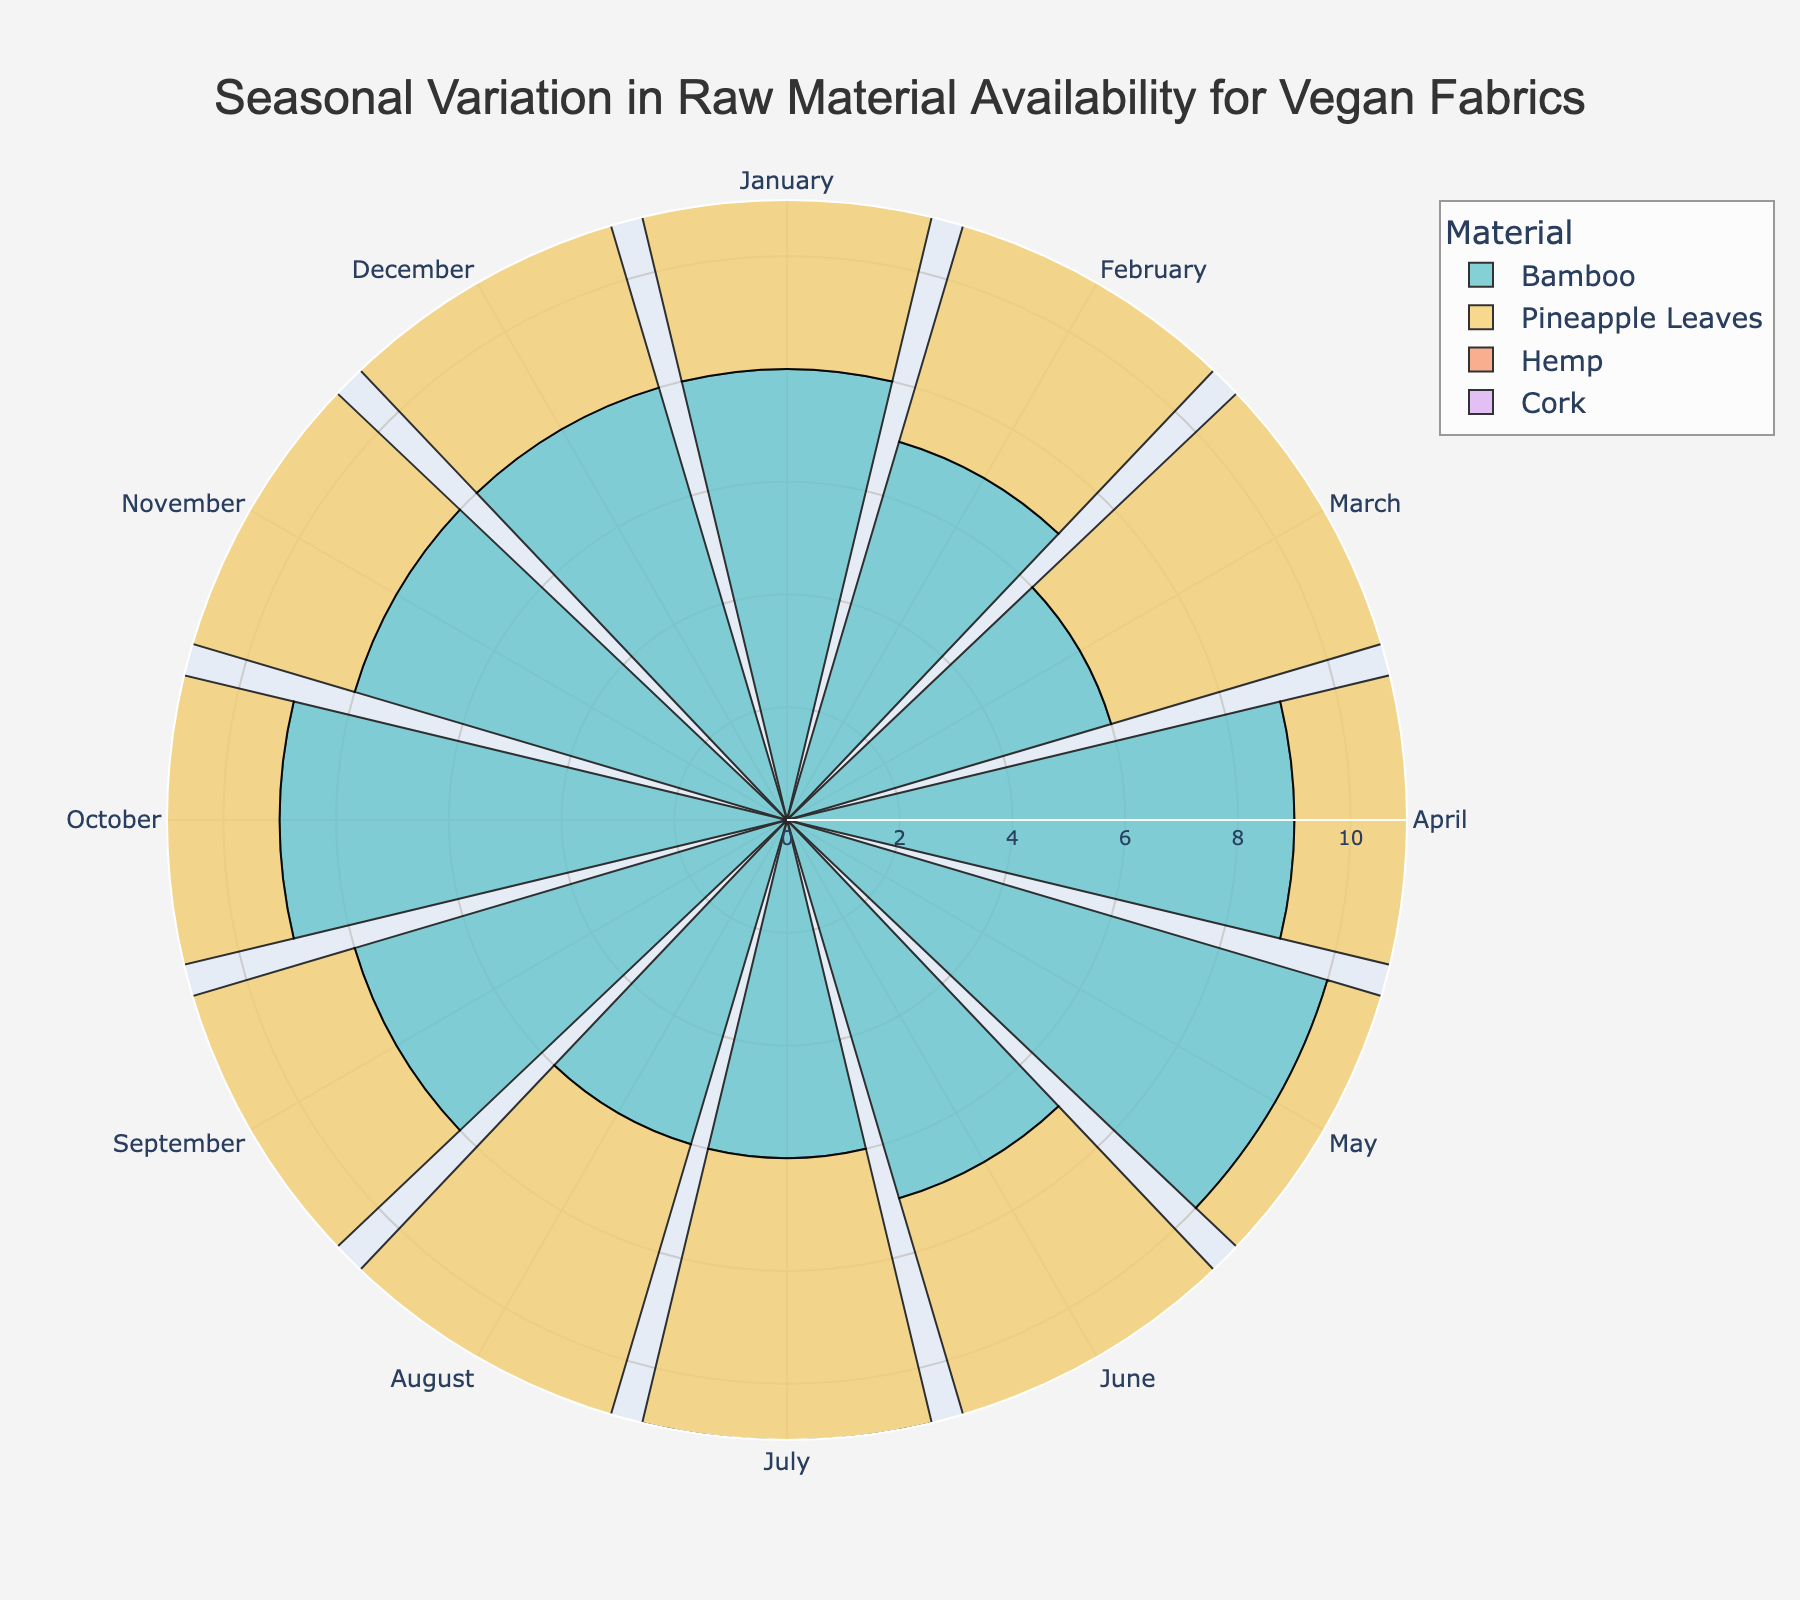What is the title of the rose chart? The title is displayed at the top center of the chart. It provides a brief description of what the chart is about.
Answer: Seasonal Variation in Raw Material Availability for Vegan Fabrics How does bamboo availability compare between January and May? Bamboo's availability index in January is 8, and in May, it is 10. By comparing these two values, we see that the availability increases from January to May.
Answer: Increases Which raw material has the lowest availability in December? By looking at the radial values for each material in December, Cork has an availability index of 4, which is the lowest compared to the others.
Answer: Cork What is the overall trend in hemp availability from January to December? Observing the hemp values for each month, we see it starts at 6 in January, peaks at 10 in May, then declines, reaching 7 in December. It generally increases till May, followed by a steady decrease.
Answer: Increases then decreases Which material shows the most consistent availability throughout the year? By comparing the range and variation in values for each material across all months, we see that Bamboo has values ranging from 6 to 10. Other materials show more fluctuation.
Answer: Bamboo Calculate the average availability index for Pineapple Leaves and Cork in the month of March. Pineapple Leaves has an index of 8, and Cork has an index of 6 in March. The average is calculated as (8 + 6) / 2.
Answer: 7 During which month is the availability of Cork highest? By examining the values for each month, Cork has its highest availability index (8) in September.
Answer: September Compare the availability index of Hemp and Pineapple Leaves in June. Which one is higher? Hemp has an availability index of 9, while Pineapple Leaves has an index of 6 in June. Hemp's availability is higher.
Answer: Hemp What month exhibits the highest availability index for Hemp, and what is the index value? Observing the radial values for each month, Hemp's highest availability index is in May with a value of 10.
Answer: May, 10 Which material has the maximum variability in availability throughout the year? By observing the range between the highest and lowest availability indices for each material, Cork ranges from 4 to 8, Pineapple Leaves from 5 to 8, Hemp from 5 to 10, and Bamboo from 6 to 10. Hemp demonstrates the highest variability.
Answer: Hemp 